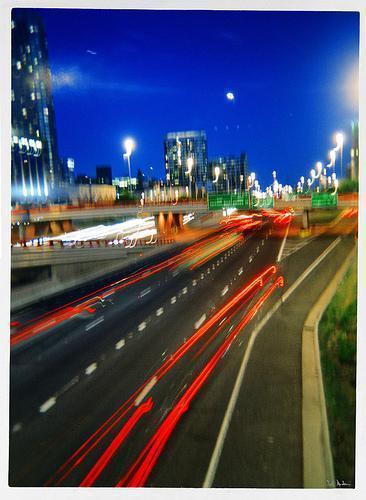How many birds flying?
Give a very brief answer. 0. 